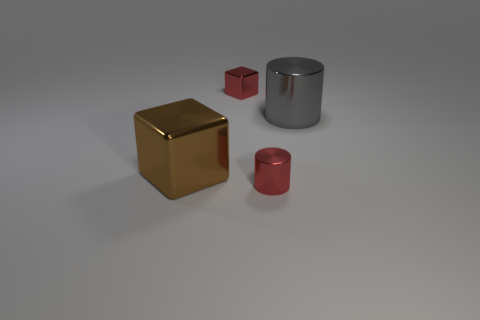Is there any other thing that has the same material as the red cylinder?
Offer a very short reply. Yes. Is the number of big objects that are to the left of the large brown metal block greater than the number of brown things?
Make the answer very short. No. Does the small cylinder have the same color as the large cube?
Make the answer very short. No. What number of small blue matte things have the same shape as the gray shiny thing?
Your answer should be very brief. 0. There is a gray object that is the same material as the small block; what is its size?
Offer a very short reply. Large. What is the color of the object that is in front of the big cylinder and behind the small metal cylinder?
Give a very brief answer. Brown. How many yellow matte balls are the same size as the brown shiny block?
Offer a terse response. 0. What is the size of the shiny thing that is the same color as the small metal cylinder?
Your answer should be compact. Small. What is the size of the thing that is both on the left side of the small metal cylinder and behind the brown shiny thing?
Your response must be concise. Small. There is a metallic cylinder that is on the left side of the cylinder that is behind the tiny red metal cylinder; what number of big brown objects are behind it?
Provide a succinct answer. 1. 